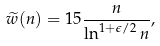<formula> <loc_0><loc_0><loc_500><loc_500>\widetilde { w } ( n ) = 1 5 \frac { n } { \ln ^ { 1 + \epsilon / 2 } n } ,</formula> 